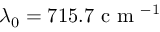Convert formula to latex. <formula><loc_0><loc_0><loc_500><loc_500>\lambda _ { 0 } = 7 1 5 . 7 c m ^ { - 1 }</formula> 